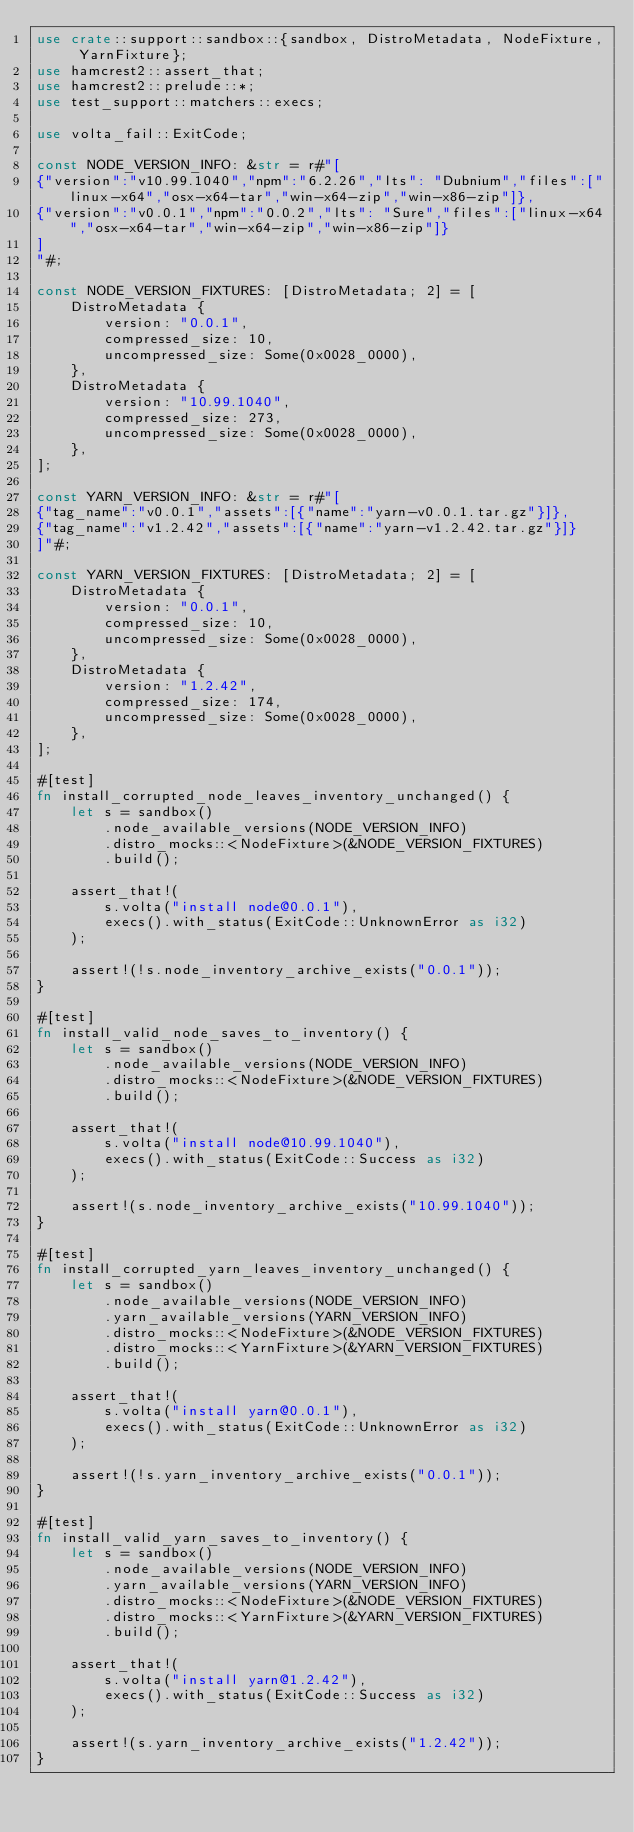<code> <loc_0><loc_0><loc_500><loc_500><_Rust_>use crate::support::sandbox::{sandbox, DistroMetadata, NodeFixture, YarnFixture};
use hamcrest2::assert_that;
use hamcrest2::prelude::*;
use test_support::matchers::execs;

use volta_fail::ExitCode;

const NODE_VERSION_INFO: &str = r#"[
{"version":"v10.99.1040","npm":"6.2.26","lts": "Dubnium","files":["linux-x64","osx-x64-tar","win-x64-zip","win-x86-zip"]},
{"version":"v0.0.1","npm":"0.0.2","lts": "Sure","files":["linux-x64","osx-x64-tar","win-x64-zip","win-x86-zip"]}
]
"#;

const NODE_VERSION_FIXTURES: [DistroMetadata; 2] = [
    DistroMetadata {
        version: "0.0.1",
        compressed_size: 10,
        uncompressed_size: Some(0x0028_0000),
    },
    DistroMetadata {
        version: "10.99.1040",
        compressed_size: 273,
        uncompressed_size: Some(0x0028_0000),
    },
];

const YARN_VERSION_INFO: &str = r#"[
{"tag_name":"v0.0.1","assets":[{"name":"yarn-v0.0.1.tar.gz"}]},
{"tag_name":"v1.2.42","assets":[{"name":"yarn-v1.2.42.tar.gz"}]}
]"#;

const YARN_VERSION_FIXTURES: [DistroMetadata; 2] = [
    DistroMetadata {
        version: "0.0.1",
        compressed_size: 10,
        uncompressed_size: Some(0x0028_0000),
    },
    DistroMetadata {
        version: "1.2.42",
        compressed_size: 174,
        uncompressed_size: Some(0x0028_0000),
    },
];

#[test]
fn install_corrupted_node_leaves_inventory_unchanged() {
    let s = sandbox()
        .node_available_versions(NODE_VERSION_INFO)
        .distro_mocks::<NodeFixture>(&NODE_VERSION_FIXTURES)
        .build();

    assert_that!(
        s.volta("install node@0.0.1"),
        execs().with_status(ExitCode::UnknownError as i32)
    );

    assert!(!s.node_inventory_archive_exists("0.0.1"));
}

#[test]
fn install_valid_node_saves_to_inventory() {
    let s = sandbox()
        .node_available_versions(NODE_VERSION_INFO)
        .distro_mocks::<NodeFixture>(&NODE_VERSION_FIXTURES)
        .build();

    assert_that!(
        s.volta("install node@10.99.1040"),
        execs().with_status(ExitCode::Success as i32)
    );

    assert!(s.node_inventory_archive_exists("10.99.1040"));
}

#[test]
fn install_corrupted_yarn_leaves_inventory_unchanged() {
    let s = sandbox()
        .node_available_versions(NODE_VERSION_INFO)
        .yarn_available_versions(YARN_VERSION_INFO)
        .distro_mocks::<NodeFixture>(&NODE_VERSION_FIXTURES)
        .distro_mocks::<YarnFixture>(&YARN_VERSION_FIXTURES)
        .build();

    assert_that!(
        s.volta("install yarn@0.0.1"),
        execs().with_status(ExitCode::UnknownError as i32)
    );

    assert!(!s.yarn_inventory_archive_exists("0.0.1"));
}

#[test]
fn install_valid_yarn_saves_to_inventory() {
    let s = sandbox()
        .node_available_versions(NODE_VERSION_INFO)
        .yarn_available_versions(YARN_VERSION_INFO)
        .distro_mocks::<NodeFixture>(&NODE_VERSION_FIXTURES)
        .distro_mocks::<YarnFixture>(&YARN_VERSION_FIXTURES)
        .build();

    assert_that!(
        s.volta("install yarn@1.2.42"),
        execs().with_status(ExitCode::Success as i32)
    );

    assert!(s.yarn_inventory_archive_exists("1.2.42"));
}
</code> 